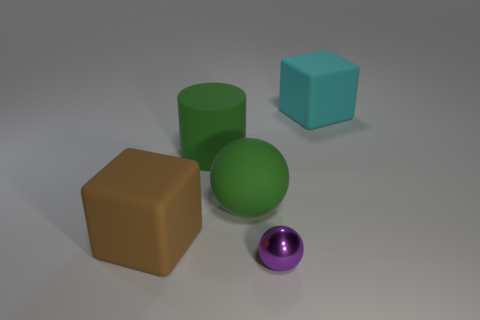Add 3 tiny gray matte objects. How many objects exist? 8 Subtract all balls. How many objects are left? 3 Add 1 big brown rubber blocks. How many big brown rubber blocks are left? 2 Add 1 cyan cubes. How many cyan cubes exist? 2 Subtract 0 red spheres. How many objects are left? 5 Subtract all big cylinders. Subtract all big cyan objects. How many objects are left? 3 